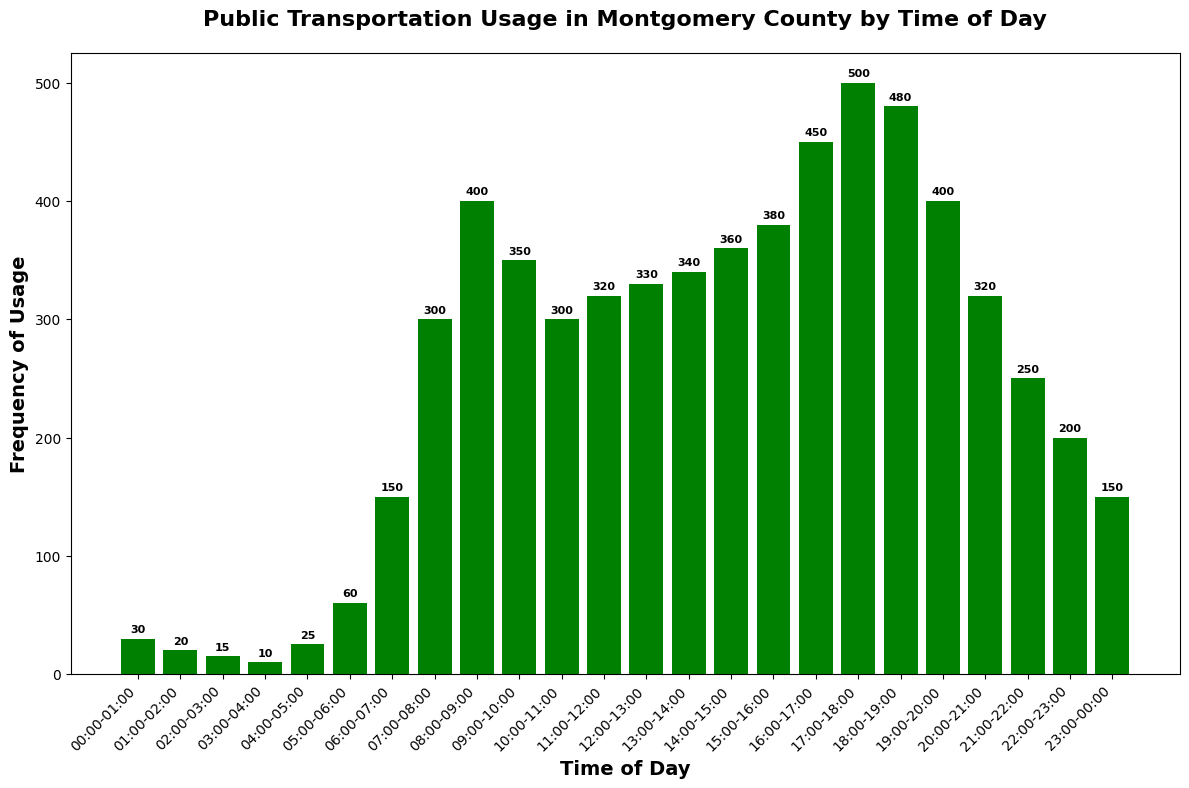What time of day sees the highest frequency of public transportation usage? The highest bar corresponds to the time frame with the most usage. The tallest bar is during 17:00-18:00 with a frequency of 500.
Answer: 17:00-18:00 How does the usage at 08:00-09:00 compare to the usage at 18:00-19:00? Compare the heights of the bars for 08:00-09:00 and 18:00-19:00. The bar for 08:00-09:00 has a frequency of 400, while 18:00-19:00 has a frequency of 480.
Answer: 18:00-19:00 is higher What is the average frequency of public transportation usage between 12:00 and 14:00? Sum the frequencies for 12:00-13:00 and 13:00-14:00, then divide by the number of time slots. (330 + 340)/2 = 335.
Answer: 335 How much greater is the frequency at 16:00-17:00 compared to 06:00-07:00? Subtract the frequency at 06:00-07:00 from the frequency at 16:00-17:00. 450 - 150 = 300.
Answer: 300 During which hours does the frequency increase steadily without any decrease? Identify consecutive time slots with increasing frequencies. From 04:00-05:00 to 09:00-10:00, the frequencies consistently increase from 25 to 350.
Answer: From 04:00-05:00 to 09:00-10:00 What is the total frequency of public transportation usage after 20:00? Sum the frequencies from 20:00-21:00 to 23:00-00:00. 320 + 250 + 200 + 150 = 920.
Answer: 920 Which time period has the lowest usage of public transportation and what is its value? Identify the shortest bar. The 03:00-04:00 slot has the lowest usage with a frequency of 10.
Answer: 03:00-04:00, 10 By how much does the public transportation frequency drop from 22:00-23:00 to 23:00-00:00? Subtract the frequency of 23:00-00:00 from the frequency of 22:00-23:00. 200 - 150 = 50.
Answer: 50 What is the median frequency of public transportation usage for the entire day? Arrange the frequencies in ascending order and find the middle value. The values in order are: 10, 15, 20, 25, 30, 60, 150, 150, 200, 250, 300, 300, 320, 320, 330, 340, 350, 360, 380, 400, 400, 450, 480, 500. The middle values are the 12th and 13th, both being 320, so the median is 320.
Answer: 320 